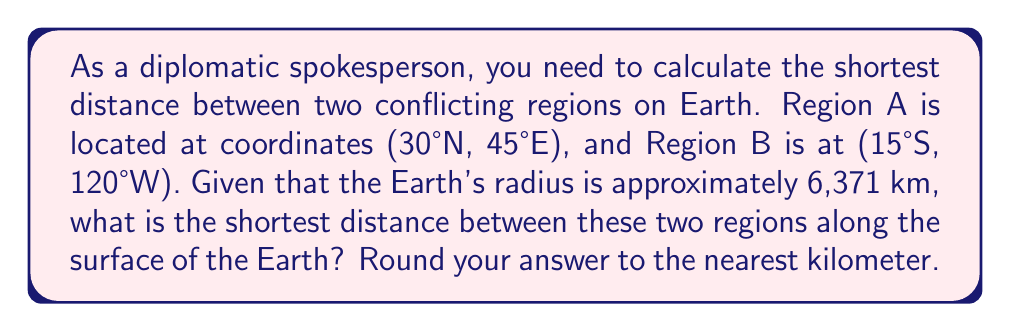What is the answer to this math problem? To find the shortest distance between two points on a sphere, we need to use the great circle distance formula. This formula calculates the arc length between two points along the surface of a sphere.

Step 1: Convert the coordinates to radians.
Region A: $\phi_1 = 30° \cdot \frac{\pi}{180} = \frac{\pi}{6}$, $\lambda_1 = 45° \cdot \frac{\pi}{180} = \frac{\pi}{4}$
Region B: $\phi_2 = -15° \cdot \frac{\pi}{180} = -\frac{\pi}{12}$, $\lambda_2 = -120° \cdot \frac{\pi}{180} = -\frac{2\pi}{3}$

Step 2: Calculate the central angle $\Delta\sigma$ using the Haversine formula:

$$\Delta\sigma = 2 \arcsin\left(\sqrt{\sin^2\left(\frac{\phi_2 - \phi_1}{2}\right) + \cos\phi_1 \cos\phi_2 \sin^2\left(\frac{\lambda_2 - \lambda_1}{2}\right)}\right)$$

$$\Delta\sigma = 2 \arcsin\left(\sqrt{\sin^2\left(\frac{-\frac{\pi}{12} - \frac{\pi}{6}}{2}\right) + \cos\frac{\pi}{6} \cos\left(-\frac{\pi}{12}\right) \sin^2\left(\frac{-\frac{2\pi}{3} - \frac{\pi}{4}}{2}\right)}\right)$$

Step 3: Calculate the distance $d$ using the formula:

$$d = R \cdot \Delta\sigma$$

where $R$ is the Earth's radius (6,371 km).

Step 4: Evaluate the expression and round to the nearest kilometer.
Answer: The shortest distance between the two conflicting regions is approximately 15,797 km. 